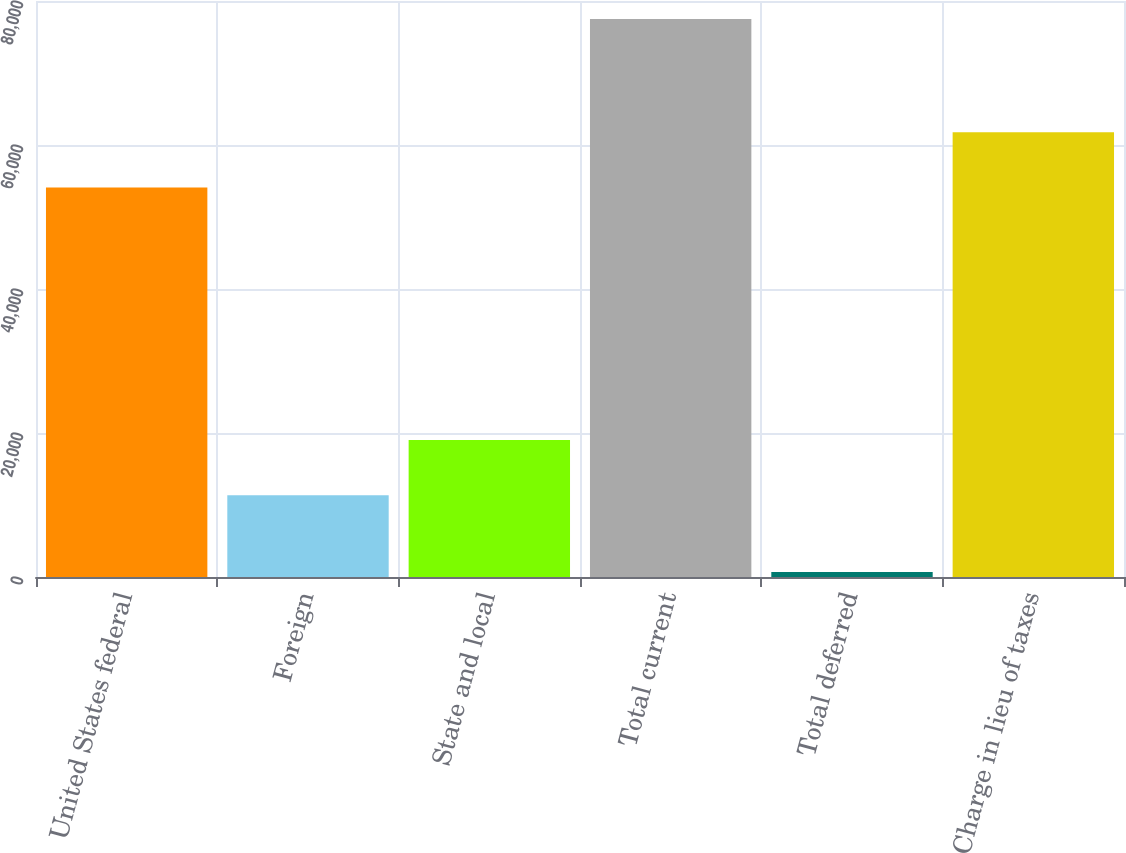<chart> <loc_0><loc_0><loc_500><loc_500><bar_chart><fcel>United States federal<fcel>Foreign<fcel>State and local<fcel>Total current<fcel>Total deferred<fcel>Charge in lieu of taxes<nl><fcel>54097<fcel>11346<fcel>19027<fcel>77504<fcel>694<fcel>61778<nl></chart> 